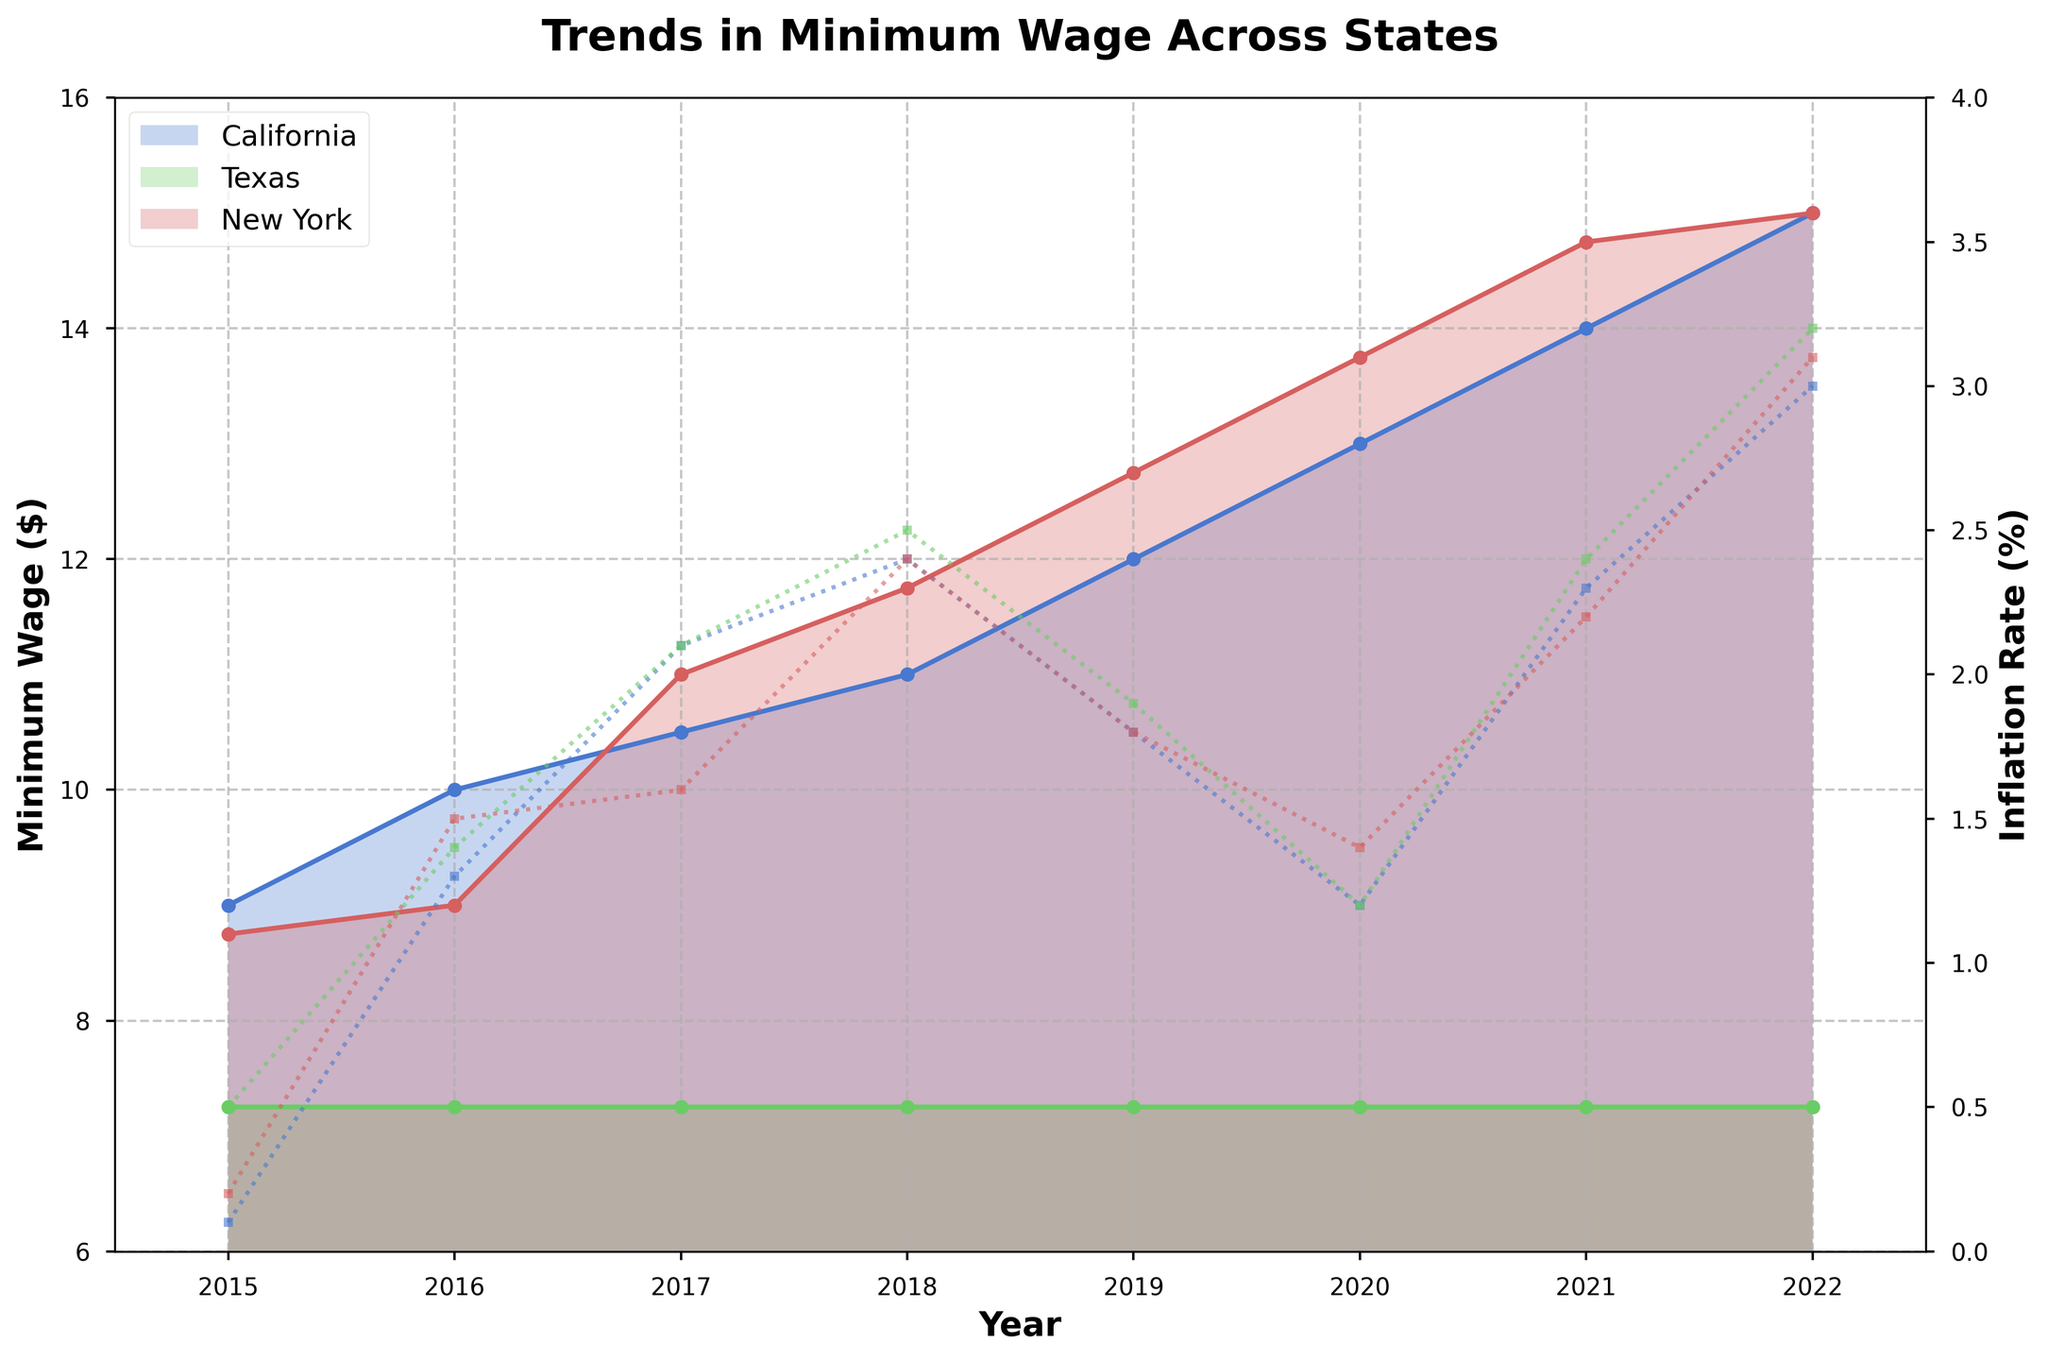What is the title of the chart? The title is located at the top center of the chart. It is bold and big, indicating the main topic of the figure.
Answer: Trends in Minimum Wage Across States Which state had the lowest minimum wage in 2022? Look at the last year on the x-axis and compare the minimum wage lines for each state. The lowest point among them will indicate the state.
Answer: Texas By how much did California's minimum wage increase from 2015 to 2022? Identify California's minimum wage values at the points corresponding to 2015 and 2022 on the x-axis. Subtract the 2015 value from the 2022 value to find the difference.
Answer: $6 Did New York's inflation rate ever surpass 3%? Observe New York's inflation rate line plotted with a dashed line. Check if it ever crosses the 3% mark on the secondary y-axis.
Answer: No Which state had the highest minimum wage increase between 2015 and 2022? Compare the increase in minimum wage for all states between 2015 and 2022. The state with the largest vertical difference in its line will be the answer.
Answer: California During which year did California and New York have the same minimum wage? Follow the lines for California and New York and see where they intersect over the years. They meet at a particular year, indicating the same minimum wage.
Answer: 2022 Is there any year where Texas’s minimum wage was adjusted? Check Texas's minimum wage line for any change or plateau over the years. Each year should be checked for any vertical shifts.
Answer: No What’s the average inflation rate in New York from 2015 to 2022? Add up New York's inflation rates for each year from 2015 to 2022 and divide by the number of years (8) to get the average.
Answer: 1.91% Compare the trend of minimum wage between 2015 and 2022 for California and Texas. How are they different? Observe the minimum wage lines for California and Texas. Texas's line remains flat while California's line indicates an increase over time. Compare the slopes and patterns to describe the trend.
Answer: California increased; Texas remained flat Is there a year when the inflation rates for all three states were the same or nearly identical? Inspect the inflation rate lines for all three states across the years and find any year where all lines converge or are very close to each other.
Answer: 2017 